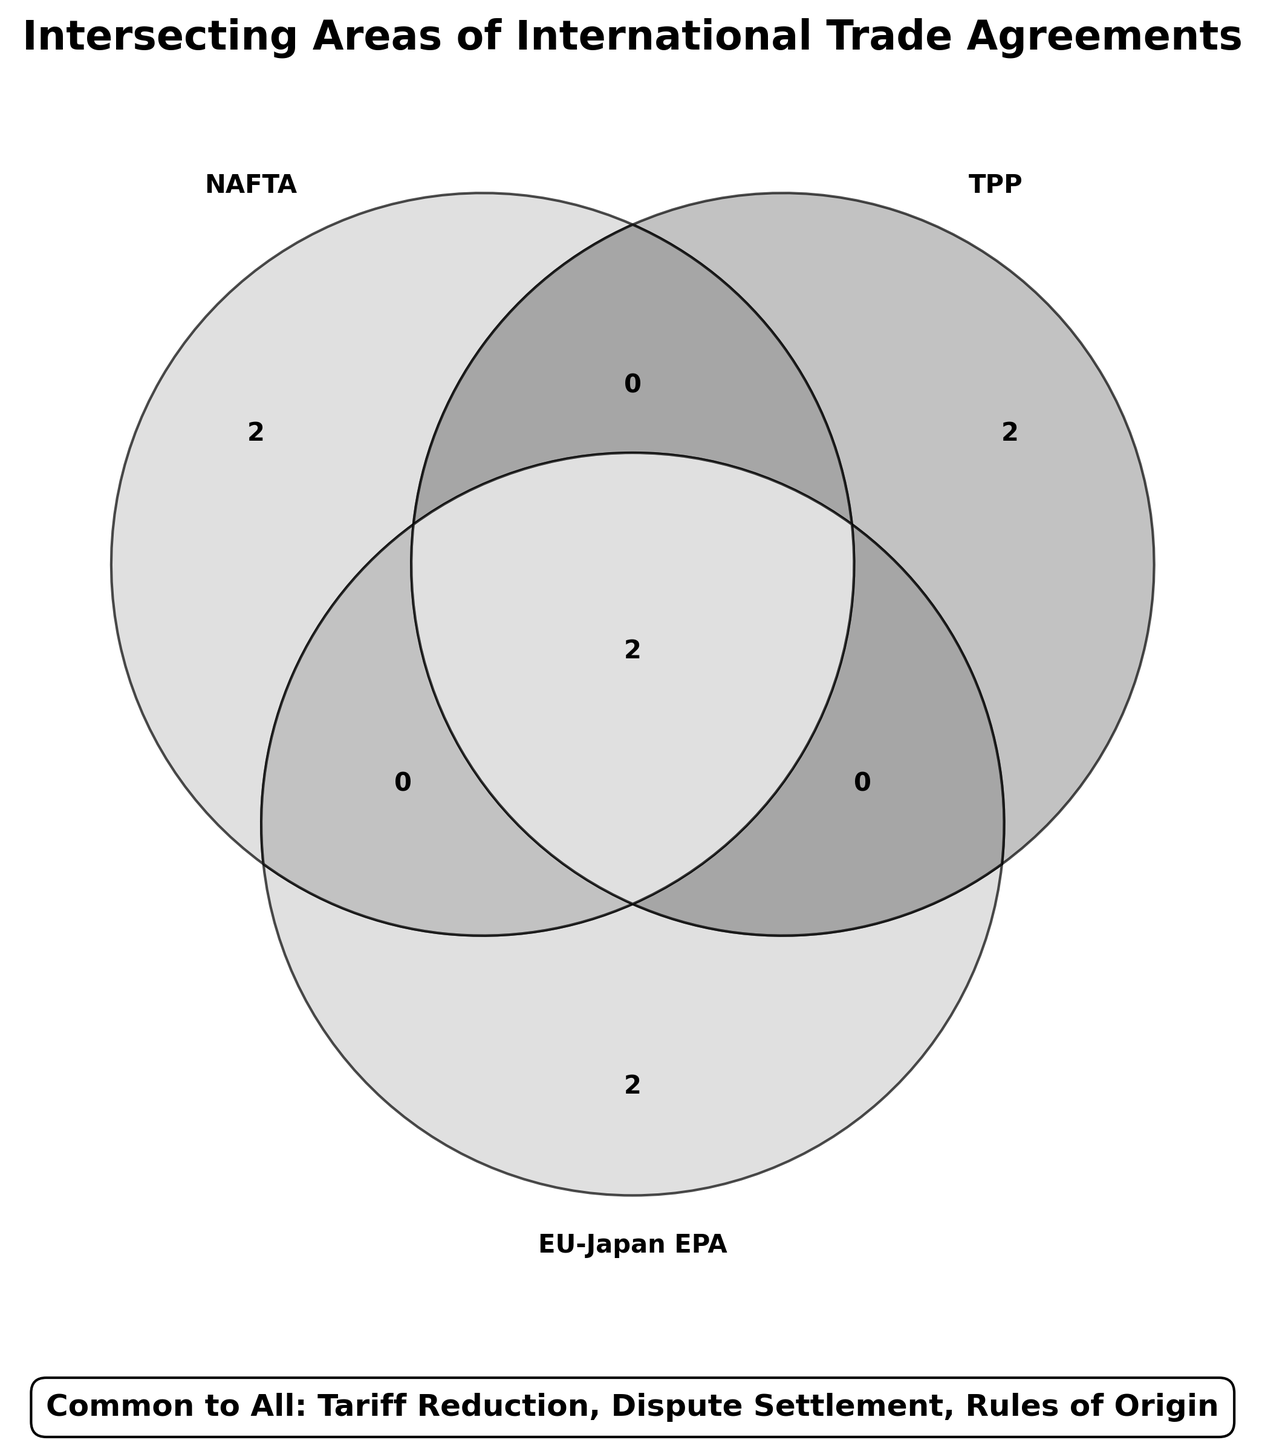What is the title of the figure? The title is located at the top of the figure, bold and in larger font size. It states "Intersecting Areas of International Trade Agreements."
Answer: Intersecting Areas of International Trade Agreements Which three trade agreements are compared in the Venn diagram? By observing the set labels, you can see the three agreements are labeled as "NAFTA", "TPP", and "EU-Japan EPA".
Answer: NAFTA, TPP, EU-Japan EPA What common areas do all three trade agreements share? Below the Venn diagram, a box displays the common items shared by all three agreements which include "Tariff Reduction," "Dispute Settlement," and "Rules of Origin."
Answer: Tariff Reduction, Dispute Settlement, Rules of Origin Which trade agreement covers "Labor Standards"? By looking at the section labeled "NAFTA" exclusively and noting the items listed, you can see that "Labor Standards" is included there.
Answer: NAFTA How many items are unique to the TPP agreement? The Venn diagram shows areas exclusive to each agreement. For TPP exclusive, "Environmental Protection" and "Digital Trade" are listed. Count them for the answer.
Answer: 2 Identify the shared areas between NAFTA and TPP but not with EU-Japan EPA. Look at the intersecting area between NAFTA and TPP circles that does not overlap with EU-Japan EPA's circle. "Services" and "Intellectual Property" are listed there.
Answer: Services, Intellectual Property Which agreement has the most unique areas not shared with the other two? Reviewing the Venn diagram, count the unique items in the specific areas of each agreement. NAFTA has "Trade in Goods" and "Labor Standards"; TPP has "Environmental Protection" and "Digital Trade"; EU-Japan EPA has "Sustainable Development" and "Regulatory Cooperation." Count them.
Answer: They all have 2 Name the areas shared exclusively by EU-Japan EPA and TPP. Check the overlap between EU-Japan EPA and TPP that does not intersect with NAFTA. Only "Services" and "Intellectual Property" are shared in this region.
Answer: Services, Intellectual Property 